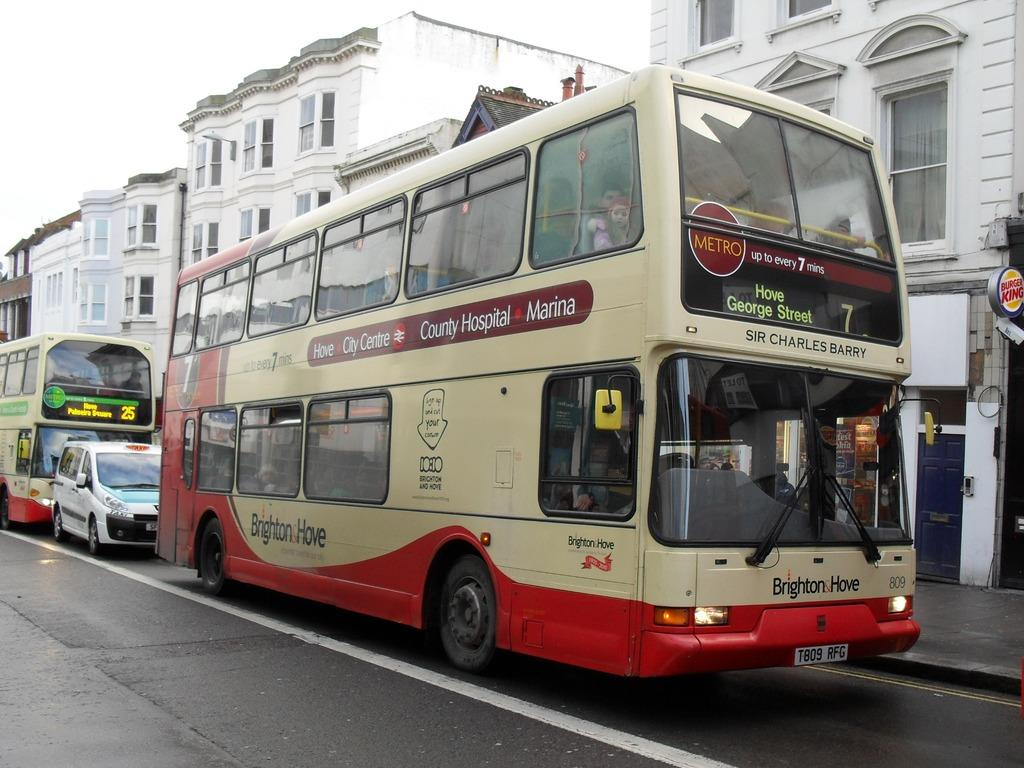<image>
Share a concise interpretation of the image provided. bus number 7 going to hove george street 